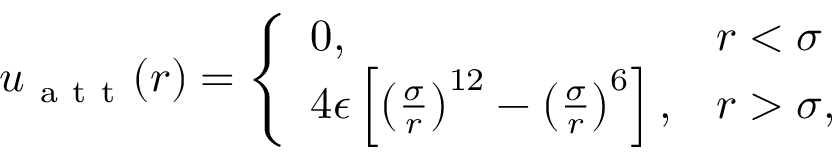Convert formula to latex. <formula><loc_0><loc_0><loc_500><loc_500>\begin{array} { r } { u _ { a t t } ( r ) = \left \{ \begin{array} { l l } { 0 , \quad } & { r < \sigma } \\ { 4 \epsilon \left [ \left ( \frac { \sigma } { r } \right ) ^ { 1 2 } - \left ( \frac { \sigma } { r } \right ) ^ { 6 } \right ] , } & { r > \sigma , } \end{array} } \end{array}</formula> 